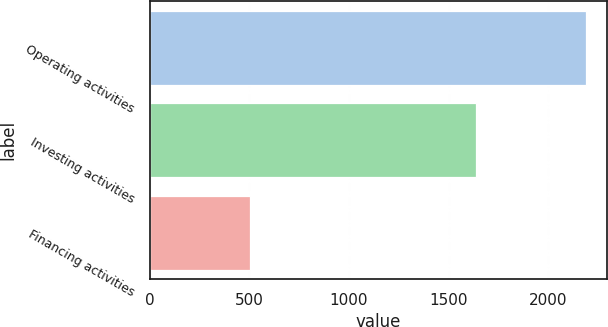Convert chart to OTSL. <chart><loc_0><loc_0><loc_500><loc_500><bar_chart><fcel>Operating activities<fcel>Investing activities<fcel>Financing activities<nl><fcel>2186.4<fcel>1638<fcel>504.3<nl></chart> 